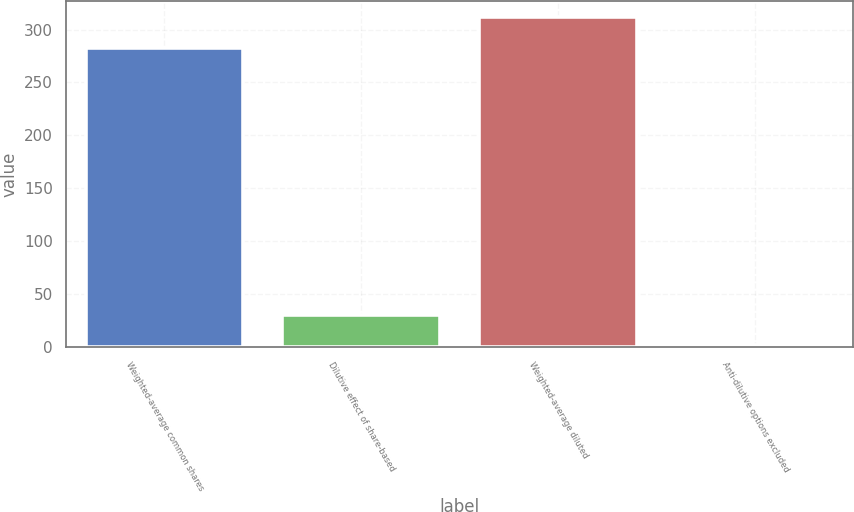<chart> <loc_0><loc_0><loc_500><loc_500><bar_chart><fcel>Weighted-average common shares<fcel>Dilutive effect of share-based<fcel>Weighted-average diluted<fcel>Anti-dilutive options excluded<nl><fcel>283<fcel>30.59<fcel>311.49<fcel>2.1<nl></chart> 